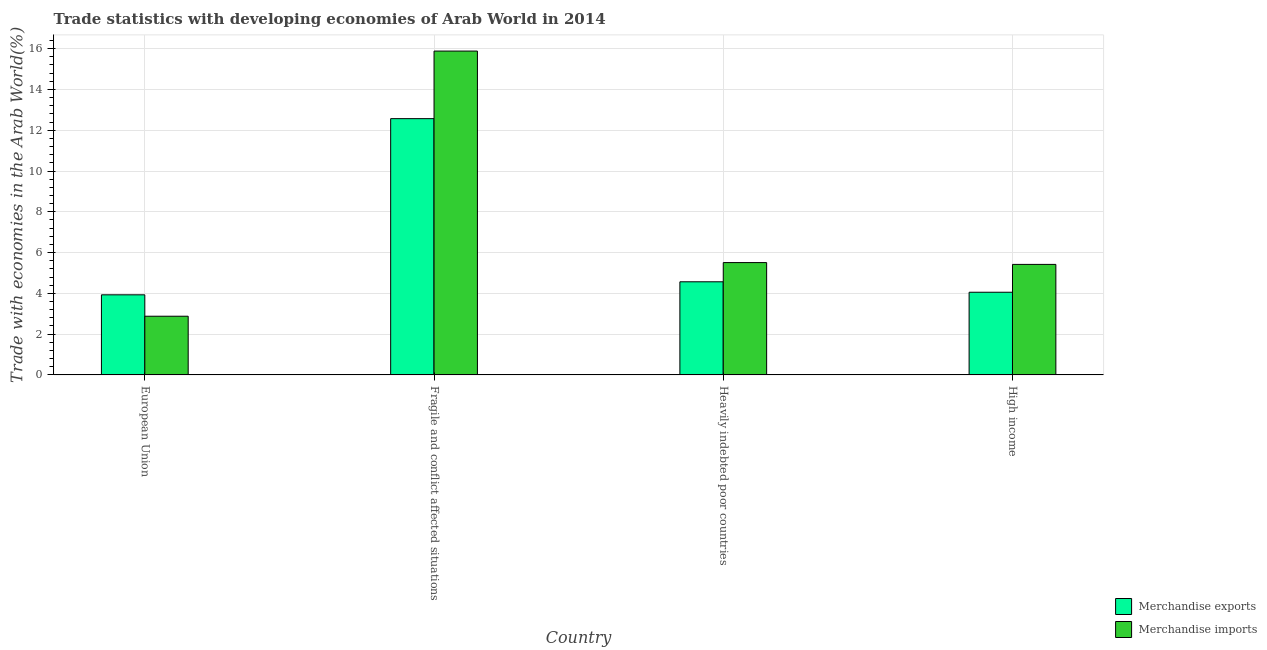How many groups of bars are there?
Keep it short and to the point. 4. Are the number of bars per tick equal to the number of legend labels?
Give a very brief answer. Yes. How many bars are there on the 3rd tick from the right?
Your answer should be compact. 2. What is the label of the 3rd group of bars from the left?
Make the answer very short. Heavily indebted poor countries. In how many cases, is the number of bars for a given country not equal to the number of legend labels?
Ensure brevity in your answer.  0. What is the merchandise exports in High income?
Your response must be concise. 4.05. Across all countries, what is the maximum merchandise imports?
Your response must be concise. 15.88. Across all countries, what is the minimum merchandise exports?
Provide a short and direct response. 3.93. In which country was the merchandise imports maximum?
Give a very brief answer. Fragile and conflict affected situations. In which country was the merchandise exports minimum?
Offer a terse response. European Union. What is the total merchandise imports in the graph?
Make the answer very short. 29.69. What is the difference between the merchandise exports in Fragile and conflict affected situations and that in High income?
Give a very brief answer. 8.51. What is the difference between the merchandise imports in High income and the merchandise exports in Fragile and conflict affected situations?
Provide a short and direct response. -7.15. What is the average merchandise imports per country?
Keep it short and to the point. 7.42. What is the difference between the merchandise exports and merchandise imports in Fragile and conflict affected situations?
Your answer should be very brief. -3.31. What is the ratio of the merchandise imports in European Union to that in Fragile and conflict affected situations?
Give a very brief answer. 0.18. Is the merchandise imports in Heavily indebted poor countries less than that in High income?
Keep it short and to the point. No. What is the difference between the highest and the second highest merchandise exports?
Ensure brevity in your answer.  8. What is the difference between the highest and the lowest merchandise imports?
Offer a terse response. 13. In how many countries, is the merchandise imports greater than the average merchandise imports taken over all countries?
Provide a succinct answer. 1. How many bars are there?
Your answer should be very brief. 8. How many countries are there in the graph?
Keep it short and to the point. 4. What is the difference between two consecutive major ticks on the Y-axis?
Offer a terse response. 2. Are the values on the major ticks of Y-axis written in scientific E-notation?
Provide a succinct answer. No. Where does the legend appear in the graph?
Offer a terse response. Bottom right. How many legend labels are there?
Keep it short and to the point. 2. How are the legend labels stacked?
Your response must be concise. Vertical. What is the title of the graph?
Provide a succinct answer. Trade statistics with developing economies of Arab World in 2014. What is the label or title of the X-axis?
Provide a succinct answer. Country. What is the label or title of the Y-axis?
Your answer should be very brief. Trade with economies in the Arab World(%). What is the Trade with economies in the Arab World(%) in Merchandise exports in European Union?
Your answer should be very brief. 3.93. What is the Trade with economies in the Arab World(%) of Merchandise imports in European Union?
Offer a terse response. 2.88. What is the Trade with economies in the Arab World(%) of Merchandise exports in Fragile and conflict affected situations?
Offer a terse response. 12.57. What is the Trade with economies in the Arab World(%) of Merchandise imports in Fragile and conflict affected situations?
Provide a short and direct response. 15.88. What is the Trade with economies in the Arab World(%) of Merchandise exports in Heavily indebted poor countries?
Provide a succinct answer. 4.57. What is the Trade with economies in the Arab World(%) of Merchandise imports in Heavily indebted poor countries?
Keep it short and to the point. 5.51. What is the Trade with economies in the Arab World(%) of Merchandise exports in High income?
Your answer should be very brief. 4.05. What is the Trade with economies in the Arab World(%) in Merchandise imports in High income?
Offer a very short reply. 5.42. Across all countries, what is the maximum Trade with economies in the Arab World(%) of Merchandise exports?
Your response must be concise. 12.57. Across all countries, what is the maximum Trade with economies in the Arab World(%) of Merchandise imports?
Your answer should be compact. 15.88. Across all countries, what is the minimum Trade with economies in the Arab World(%) in Merchandise exports?
Your response must be concise. 3.93. Across all countries, what is the minimum Trade with economies in the Arab World(%) in Merchandise imports?
Provide a succinct answer. 2.88. What is the total Trade with economies in the Arab World(%) of Merchandise exports in the graph?
Give a very brief answer. 25.12. What is the total Trade with economies in the Arab World(%) of Merchandise imports in the graph?
Your answer should be very brief. 29.69. What is the difference between the Trade with economies in the Arab World(%) in Merchandise exports in European Union and that in Fragile and conflict affected situations?
Offer a very short reply. -8.64. What is the difference between the Trade with economies in the Arab World(%) in Merchandise imports in European Union and that in Fragile and conflict affected situations?
Offer a terse response. -13. What is the difference between the Trade with economies in the Arab World(%) in Merchandise exports in European Union and that in Heavily indebted poor countries?
Your answer should be very brief. -0.64. What is the difference between the Trade with economies in the Arab World(%) in Merchandise imports in European Union and that in Heavily indebted poor countries?
Provide a short and direct response. -2.63. What is the difference between the Trade with economies in the Arab World(%) in Merchandise exports in European Union and that in High income?
Ensure brevity in your answer.  -0.13. What is the difference between the Trade with economies in the Arab World(%) in Merchandise imports in European Union and that in High income?
Make the answer very short. -2.54. What is the difference between the Trade with economies in the Arab World(%) in Merchandise exports in Fragile and conflict affected situations and that in Heavily indebted poor countries?
Your answer should be compact. 8. What is the difference between the Trade with economies in the Arab World(%) in Merchandise imports in Fragile and conflict affected situations and that in Heavily indebted poor countries?
Your answer should be compact. 10.37. What is the difference between the Trade with economies in the Arab World(%) of Merchandise exports in Fragile and conflict affected situations and that in High income?
Your answer should be very brief. 8.51. What is the difference between the Trade with economies in the Arab World(%) in Merchandise imports in Fragile and conflict affected situations and that in High income?
Your answer should be very brief. 10.46. What is the difference between the Trade with economies in the Arab World(%) of Merchandise exports in Heavily indebted poor countries and that in High income?
Your answer should be very brief. 0.51. What is the difference between the Trade with economies in the Arab World(%) of Merchandise imports in Heavily indebted poor countries and that in High income?
Provide a short and direct response. 0.09. What is the difference between the Trade with economies in the Arab World(%) of Merchandise exports in European Union and the Trade with economies in the Arab World(%) of Merchandise imports in Fragile and conflict affected situations?
Ensure brevity in your answer.  -11.95. What is the difference between the Trade with economies in the Arab World(%) of Merchandise exports in European Union and the Trade with economies in the Arab World(%) of Merchandise imports in Heavily indebted poor countries?
Your answer should be compact. -1.58. What is the difference between the Trade with economies in the Arab World(%) in Merchandise exports in European Union and the Trade with economies in the Arab World(%) in Merchandise imports in High income?
Provide a short and direct response. -1.49. What is the difference between the Trade with economies in the Arab World(%) in Merchandise exports in Fragile and conflict affected situations and the Trade with economies in the Arab World(%) in Merchandise imports in Heavily indebted poor countries?
Offer a terse response. 7.06. What is the difference between the Trade with economies in the Arab World(%) of Merchandise exports in Fragile and conflict affected situations and the Trade with economies in the Arab World(%) of Merchandise imports in High income?
Your response must be concise. 7.15. What is the difference between the Trade with economies in the Arab World(%) in Merchandise exports in Heavily indebted poor countries and the Trade with economies in the Arab World(%) in Merchandise imports in High income?
Your response must be concise. -0.85. What is the average Trade with economies in the Arab World(%) in Merchandise exports per country?
Make the answer very short. 6.28. What is the average Trade with economies in the Arab World(%) of Merchandise imports per country?
Make the answer very short. 7.42. What is the difference between the Trade with economies in the Arab World(%) of Merchandise exports and Trade with economies in the Arab World(%) of Merchandise imports in European Union?
Provide a succinct answer. 1.05. What is the difference between the Trade with economies in the Arab World(%) of Merchandise exports and Trade with economies in the Arab World(%) of Merchandise imports in Fragile and conflict affected situations?
Make the answer very short. -3.31. What is the difference between the Trade with economies in the Arab World(%) of Merchandise exports and Trade with economies in the Arab World(%) of Merchandise imports in Heavily indebted poor countries?
Provide a short and direct response. -0.94. What is the difference between the Trade with economies in the Arab World(%) in Merchandise exports and Trade with economies in the Arab World(%) in Merchandise imports in High income?
Offer a very short reply. -1.37. What is the ratio of the Trade with economies in the Arab World(%) of Merchandise exports in European Union to that in Fragile and conflict affected situations?
Offer a very short reply. 0.31. What is the ratio of the Trade with economies in the Arab World(%) in Merchandise imports in European Union to that in Fragile and conflict affected situations?
Offer a very short reply. 0.18. What is the ratio of the Trade with economies in the Arab World(%) of Merchandise exports in European Union to that in Heavily indebted poor countries?
Offer a terse response. 0.86. What is the ratio of the Trade with economies in the Arab World(%) of Merchandise imports in European Union to that in Heavily indebted poor countries?
Provide a succinct answer. 0.52. What is the ratio of the Trade with economies in the Arab World(%) of Merchandise exports in European Union to that in High income?
Your response must be concise. 0.97. What is the ratio of the Trade with economies in the Arab World(%) in Merchandise imports in European Union to that in High income?
Ensure brevity in your answer.  0.53. What is the ratio of the Trade with economies in the Arab World(%) in Merchandise exports in Fragile and conflict affected situations to that in Heavily indebted poor countries?
Keep it short and to the point. 2.75. What is the ratio of the Trade with economies in the Arab World(%) of Merchandise imports in Fragile and conflict affected situations to that in Heavily indebted poor countries?
Ensure brevity in your answer.  2.88. What is the ratio of the Trade with economies in the Arab World(%) in Merchandise exports in Fragile and conflict affected situations to that in High income?
Provide a succinct answer. 3.1. What is the ratio of the Trade with economies in the Arab World(%) in Merchandise imports in Fragile and conflict affected situations to that in High income?
Keep it short and to the point. 2.93. What is the ratio of the Trade with economies in the Arab World(%) of Merchandise exports in Heavily indebted poor countries to that in High income?
Your answer should be very brief. 1.13. What is the ratio of the Trade with economies in the Arab World(%) of Merchandise imports in Heavily indebted poor countries to that in High income?
Offer a very short reply. 1.02. What is the difference between the highest and the second highest Trade with economies in the Arab World(%) in Merchandise exports?
Your answer should be very brief. 8. What is the difference between the highest and the second highest Trade with economies in the Arab World(%) of Merchandise imports?
Give a very brief answer. 10.37. What is the difference between the highest and the lowest Trade with economies in the Arab World(%) of Merchandise exports?
Give a very brief answer. 8.64. What is the difference between the highest and the lowest Trade with economies in the Arab World(%) of Merchandise imports?
Your answer should be compact. 13. 